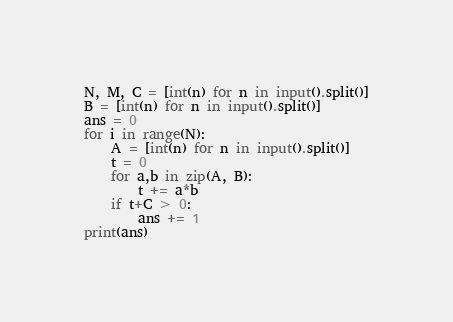<code> <loc_0><loc_0><loc_500><loc_500><_Python_>N, M, C = [int(n) for n in input().split()]
B = [int(n) for n in input().split()]
ans = 0
for i in range(N):
    A = [int(n) for n in input().split()]
    t = 0
    for a,b in zip(A, B):
        t += a*b
    if t+C > 0:
        ans += 1
print(ans)
</code> 